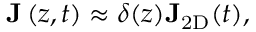Convert formula to latex. <formula><loc_0><loc_0><loc_500><loc_500>{ J } \left ( z , t \right ) \approx \delta ( z ) { J } _ { 2 D } ( t ) ,</formula> 